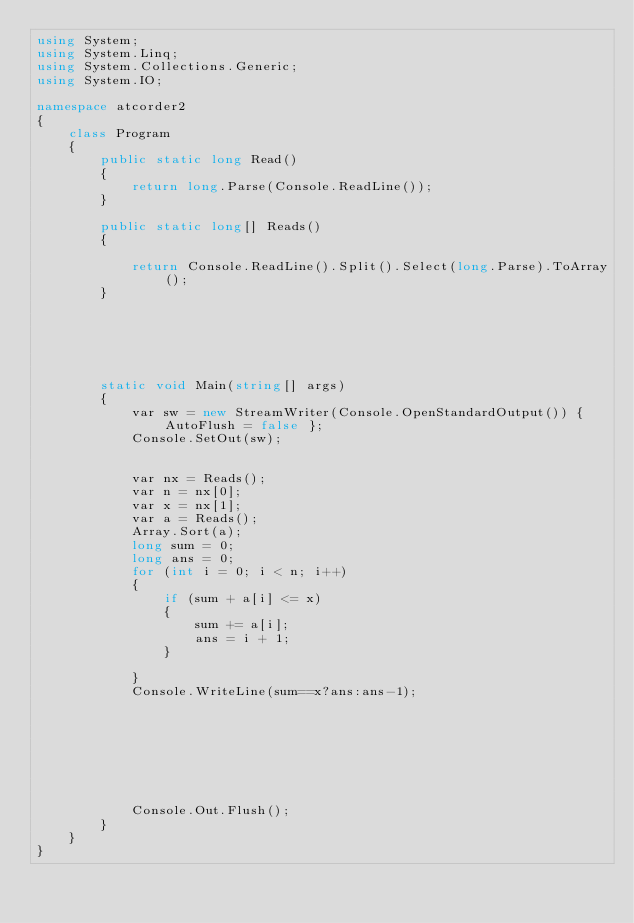Convert code to text. <code><loc_0><loc_0><loc_500><loc_500><_C#_>using System;
using System.Linq;
using System.Collections.Generic;
using System.IO;

namespace atcorder2
{
    class Program
    {
        public static long Read()
        {
            return long.Parse(Console.ReadLine());
        }

        public static long[] Reads()
        {

            return Console.ReadLine().Split().Select(long.Parse).ToArray();
        }






        static void Main(string[] args)
        {
            var sw = new StreamWriter(Console.OpenStandardOutput()) { AutoFlush = false };
            Console.SetOut(sw);


            var nx = Reads();
            var n = nx[0];
            var x = nx[1];
            var a = Reads();
            Array.Sort(a);
            long sum = 0;
            long ans = 0;
            for (int i = 0; i < n; i++)
            {
                if (sum + a[i] <= x)
                {
                    sum += a[i];
                    ans = i + 1;
                }

            }
            Console.WriteLine(sum==x?ans:ans-1);
              
            
           
           
            



            Console.Out.Flush();
        }
    }
}


</code> 